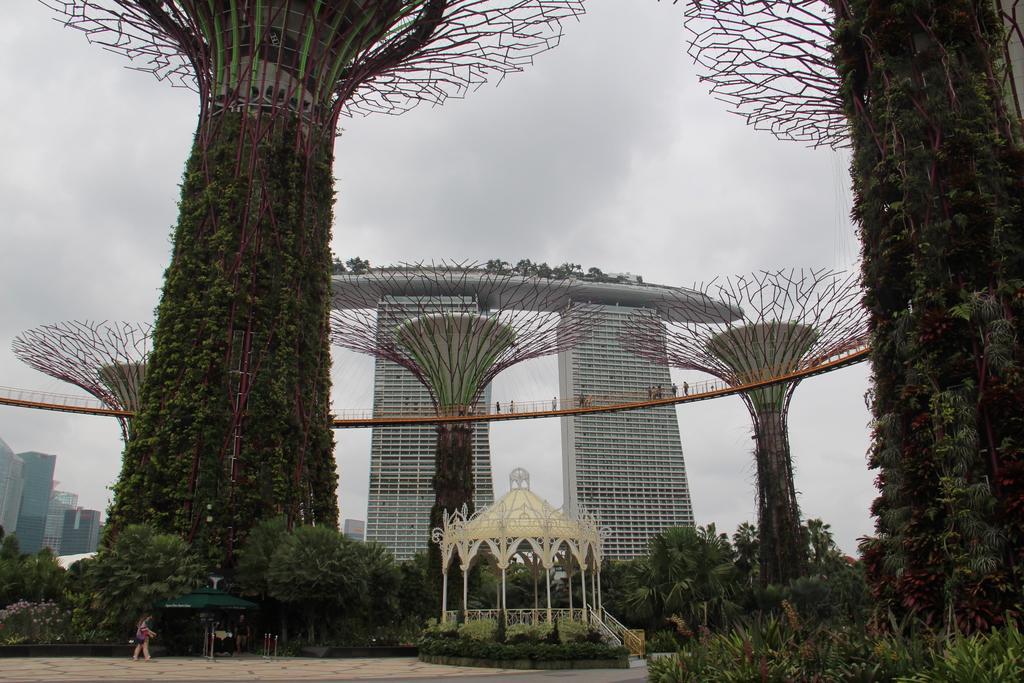Can you describe this image briefly? In this image I can see number of plants, number of trees, number of buildings, clouds and the sky. On the bottom side of this image I can see open sheds and two persons. 